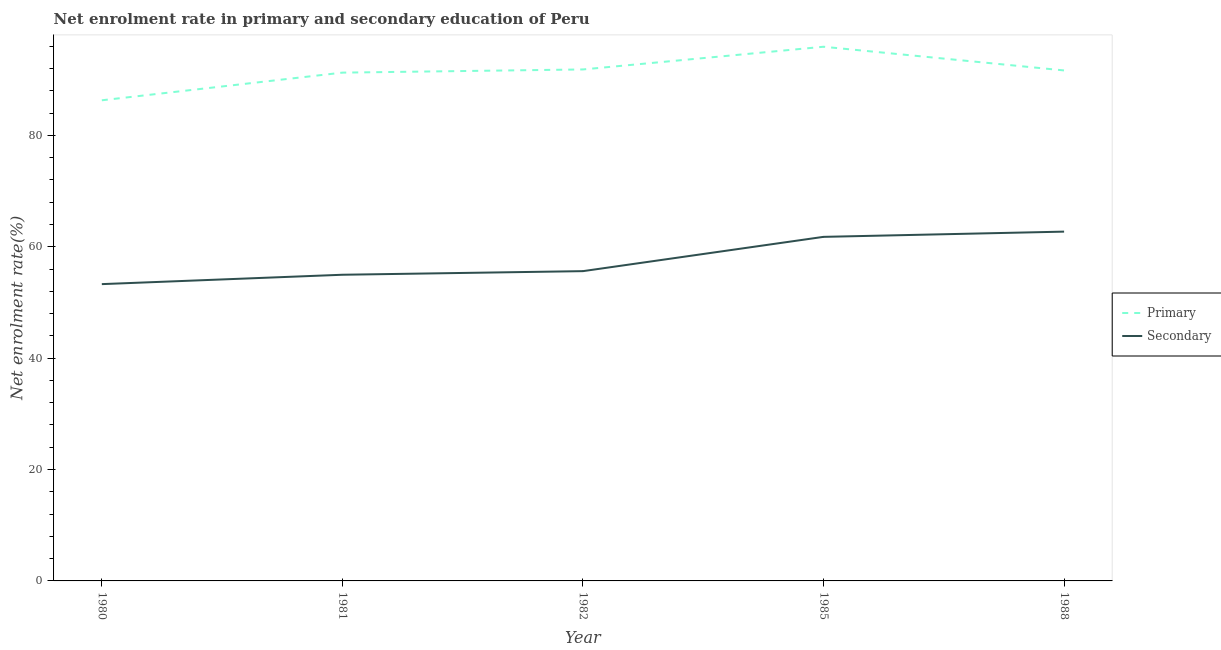How many different coloured lines are there?
Offer a very short reply. 2. Is the number of lines equal to the number of legend labels?
Your response must be concise. Yes. What is the enrollment rate in primary education in 1981?
Offer a very short reply. 91.27. Across all years, what is the maximum enrollment rate in primary education?
Keep it short and to the point. 95.92. Across all years, what is the minimum enrollment rate in secondary education?
Your answer should be compact. 53.29. In which year was the enrollment rate in primary education maximum?
Offer a very short reply. 1985. In which year was the enrollment rate in primary education minimum?
Ensure brevity in your answer.  1980. What is the total enrollment rate in primary education in the graph?
Offer a very short reply. 456.98. What is the difference between the enrollment rate in secondary education in 1980 and that in 1985?
Ensure brevity in your answer.  -8.49. What is the difference between the enrollment rate in secondary education in 1985 and the enrollment rate in primary education in 1982?
Offer a very short reply. -30.06. What is the average enrollment rate in primary education per year?
Offer a very short reply. 91.4. In the year 1988, what is the difference between the enrollment rate in secondary education and enrollment rate in primary education?
Offer a very short reply. -28.94. What is the ratio of the enrollment rate in primary education in 1982 to that in 1988?
Provide a succinct answer. 1. What is the difference between the highest and the second highest enrollment rate in secondary education?
Your answer should be compact. 0.94. What is the difference between the highest and the lowest enrollment rate in primary education?
Keep it short and to the point. 9.61. In how many years, is the enrollment rate in primary education greater than the average enrollment rate in primary education taken over all years?
Provide a short and direct response. 3. Is the sum of the enrollment rate in primary education in 1981 and 1985 greater than the maximum enrollment rate in secondary education across all years?
Ensure brevity in your answer.  Yes. Is the enrollment rate in secondary education strictly greater than the enrollment rate in primary education over the years?
Ensure brevity in your answer.  No. How many lines are there?
Offer a terse response. 2. How many years are there in the graph?
Your response must be concise. 5. Does the graph contain grids?
Your answer should be very brief. No. How many legend labels are there?
Your response must be concise. 2. How are the legend labels stacked?
Your response must be concise. Vertical. What is the title of the graph?
Provide a succinct answer. Net enrolment rate in primary and secondary education of Peru. What is the label or title of the Y-axis?
Provide a short and direct response. Net enrolment rate(%). What is the Net enrolment rate(%) in Primary in 1980?
Your answer should be compact. 86.3. What is the Net enrolment rate(%) of Secondary in 1980?
Your response must be concise. 53.29. What is the Net enrolment rate(%) in Primary in 1981?
Make the answer very short. 91.27. What is the Net enrolment rate(%) in Secondary in 1981?
Your answer should be compact. 54.97. What is the Net enrolment rate(%) of Primary in 1982?
Your answer should be compact. 91.84. What is the Net enrolment rate(%) of Secondary in 1982?
Offer a very short reply. 55.62. What is the Net enrolment rate(%) in Primary in 1985?
Provide a succinct answer. 95.92. What is the Net enrolment rate(%) of Secondary in 1985?
Offer a terse response. 61.78. What is the Net enrolment rate(%) in Primary in 1988?
Ensure brevity in your answer.  91.66. What is the Net enrolment rate(%) in Secondary in 1988?
Your answer should be compact. 62.72. Across all years, what is the maximum Net enrolment rate(%) of Primary?
Provide a succinct answer. 95.92. Across all years, what is the maximum Net enrolment rate(%) of Secondary?
Make the answer very short. 62.72. Across all years, what is the minimum Net enrolment rate(%) of Primary?
Provide a short and direct response. 86.3. Across all years, what is the minimum Net enrolment rate(%) of Secondary?
Provide a short and direct response. 53.29. What is the total Net enrolment rate(%) of Primary in the graph?
Offer a very short reply. 456.98. What is the total Net enrolment rate(%) of Secondary in the graph?
Make the answer very short. 288.39. What is the difference between the Net enrolment rate(%) of Primary in 1980 and that in 1981?
Offer a very short reply. -4.97. What is the difference between the Net enrolment rate(%) in Secondary in 1980 and that in 1981?
Give a very brief answer. -1.68. What is the difference between the Net enrolment rate(%) of Primary in 1980 and that in 1982?
Keep it short and to the point. -5.54. What is the difference between the Net enrolment rate(%) of Secondary in 1980 and that in 1982?
Your answer should be compact. -2.33. What is the difference between the Net enrolment rate(%) of Primary in 1980 and that in 1985?
Give a very brief answer. -9.61. What is the difference between the Net enrolment rate(%) of Secondary in 1980 and that in 1985?
Your response must be concise. -8.49. What is the difference between the Net enrolment rate(%) in Primary in 1980 and that in 1988?
Ensure brevity in your answer.  -5.36. What is the difference between the Net enrolment rate(%) in Secondary in 1980 and that in 1988?
Keep it short and to the point. -9.43. What is the difference between the Net enrolment rate(%) of Primary in 1981 and that in 1982?
Your answer should be very brief. -0.57. What is the difference between the Net enrolment rate(%) of Secondary in 1981 and that in 1982?
Your answer should be very brief. -0.65. What is the difference between the Net enrolment rate(%) of Primary in 1981 and that in 1985?
Provide a short and direct response. -4.65. What is the difference between the Net enrolment rate(%) in Secondary in 1981 and that in 1985?
Provide a succinct answer. -6.8. What is the difference between the Net enrolment rate(%) in Primary in 1981 and that in 1988?
Make the answer very short. -0.39. What is the difference between the Net enrolment rate(%) of Secondary in 1981 and that in 1988?
Offer a very short reply. -7.74. What is the difference between the Net enrolment rate(%) of Primary in 1982 and that in 1985?
Ensure brevity in your answer.  -4.08. What is the difference between the Net enrolment rate(%) in Secondary in 1982 and that in 1985?
Offer a terse response. -6.16. What is the difference between the Net enrolment rate(%) of Primary in 1982 and that in 1988?
Give a very brief answer. 0.18. What is the difference between the Net enrolment rate(%) of Secondary in 1982 and that in 1988?
Your response must be concise. -7.1. What is the difference between the Net enrolment rate(%) in Primary in 1985 and that in 1988?
Your answer should be very brief. 4.25. What is the difference between the Net enrolment rate(%) of Secondary in 1985 and that in 1988?
Provide a succinct answer. -0.94. What is the difference between the Net enrolment rate(%) in Primary in 1980 and the Net enrolment rate(%) in Secondary in 1981?
Your response must be concise. 31.33. What is the difference between the Net enrolment rate(%) in Primary in 1980 and the Net enrolment rate(%) in Secondary in 1982?
Offer a terse response. 30.68. What is the difference between the Net enrolment rate(%) of Primary in 1980 and the Net enrolment rate(%) of Secondary in 1985?
Provide a succinct answer. 24.52. What is the difference between the Net enrolment rate(%) in Primary in 1980 and the Net enrolment rate(%) in Secondary in 1988?
Give a very brief answer. 23.58. What is the difference between the Net enrolment rate(%) in Primary in 1981 and the Net enrolment rate(%) in Secondary in 1982?
Provide a short and direct response. 35.64. What is the difference between the Net enrolment rate(%) in Primary in 1981 and the Net enrolment rate(%) in Secondary in 1985?
Provide a succinct answer. 29.49. What is the difference between the Net enrolment rate(%) in Primary in 1981 and the Net enrolment rate(%) in Secondary in 1988?
Ensure brevity in your answer.  28.55. What is the difference between the Net enrolment rate(%) of Primary in 1982 and the Net enrolment rate(%) of Secondary in 1985?
Give a very brief answer. 30.06. What is the difference between the Net enrolment rate(%) of Primary in 1982 and the Net enrolment rate(%) of Secondary in 1988?
Provide a short and direct response. 29.12. What is the difference between the Net enrolment rate(%) in Primary in 1985 and the Net enrolment rate(%) in Secondary in 1988?
Offer a very short reply. 33.2. What is the average Net enrolment rate(%) in Primary per year?
Offer a terse response. 91.4. What is the average Net enrolment rate(%) in Secondary per year?
Ensure brevity in your answer.  57.68. In the year 1980, what is the difference between the Net enrolment rate(%) of Primary and Net enrolment rate(%) of Secondary?
Offer a very short reply. 33.01. In the year 1981, what is the difference between the Net enrolment rate(%) of Primary and Net enrolment rate(%) of Secondary?
Offer a terse response. 36.29. In the year 1982, what is the difference between the Net enrolment rate(%) in Primary and Net enrolment rate(%) in Secondary?
Provide a succinct answer. 36.22. In the year 1985, what is the difference between the Net enrolment rate(%) of Primary and Net enrolment rate(%) of Secondary?
Keep it short and to the point. 34.14. In the year 1988, what is the difference between the Net enrolment rate(%) of Primary and Net enrolment rate(%) of Secondary?
Your response must be concise. 28.94. What is the ratio of the Net enrolment rate(%) in Primary in 1980 to that in 1981?
Your answer should be compact. 0.95. What is the ratio of the Net enrolment rate(%) of Secondary in 1980 to that in 1981?
Give a very brief answer. 0.97. What is the ratio of the Net enrolment rate(%) in Primary in 1980 to that in 1982?
Offer a terse response. 0.94. What is the ratio of the Net enrolment rate(%) in Secondary in 1980 to that in 1982?
Provide a succinct answer. 0.96. What is the ratio of the Net enrolment rate(%) in Primary in 1980 to that in 1985?
Make the answer very short. 0.9. What is the ratio of the Net enrolment rate(%) of Secondary in 1980 to that in 1985?
Offer a very short reply. 0.86. What is the ratio of the Net enrolment rate(%) of Primary in 1980 to that in 1988?
Provide a short and direct response. 0.94. What is the ratio of the Net enrolment rate(%) in Secondary in 1980 to that in 1988?
Provide a short and direct response. 0.85. What is the ratio of the Net enrolment rate(%) of Primary in 1981 to that in 1982?
Keep it short and to the point. 0.99. What is the ratio of the Net enrolment rate(%) of Secondary in 1981 to that in 1982?
Offer a very short reply. 0.99. What is the ratio of the Net enrolment rate(%) of Primary in 1981 to that in 1985?
Provide a short and direct response. 0.95. What is the ratio of the Net enrolment rate(%) in Secondary in 1981 to that in 1985?
Make the answer very short. 0.89. What is the ratio of the Net enrolment rate(%) in Primary in 1981 to that in 1988?
Your answer should be very brief. 1. What is the ratio of the Net enrolment rate(%) of Secondary in 1981 to that in 1988?
Your answer should be compact. 0.88. What is the ratio of the Net enrolment rate(%) of Primary in 1982 to that in 1985?
Give a very brief answer. 0.96. What is the ratio of the Net enrolment rate(%) of Secondary in 1982 to that in 1985?
Your response must be concise. 0.9. What is the ratio of the Net enrolment rate(%) in Secondary in 1982 to that in 1988?
Your answer should be very brief. 0.89. What is the ratio of the Net enrolment rate(%) in Primary in 1985 to that in 1988?
Your response must be concise. 1.05. What is the difference between the highest and the second highest Net enrolment rate(%) of Primary?
Your answer should be compact. 4.08. What is the difference between the highest and the second highest Net enrolment rate(%) of Secondary?
Your response must be concise. 0.94. What is the difference between the highest and the lowest Net enrolment rate(%) in Primary?
Provide a succinct answer. 9.61. What is the difference between the highest and the lowest Net enrolment rate(%) in Secondary?
Your answer should be compact. 9.43. 